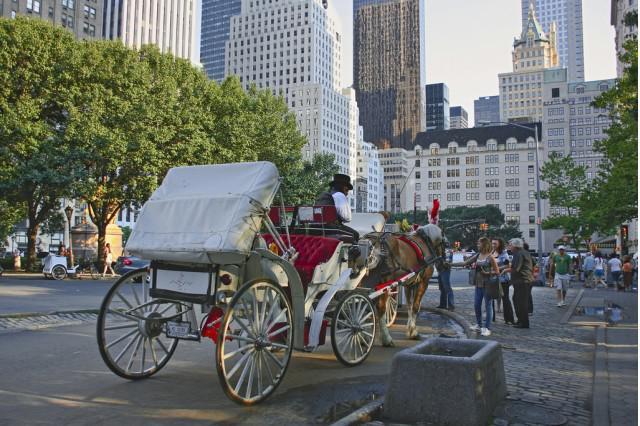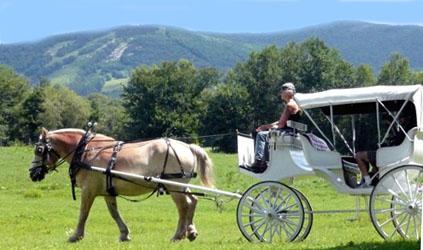The first image is the image on the left, the second image is the image on the right. Considering the images on both sides, is "The left image has a horse carriage in an urban area." valid? Answer yes or no. Yes. The first image is the image on the left, the second image is the image on the right. Given the left and right images, does the statement "The horse-drawn cart on the right side is located in a rural setting." hold true? Answer yes or no. Yes. 